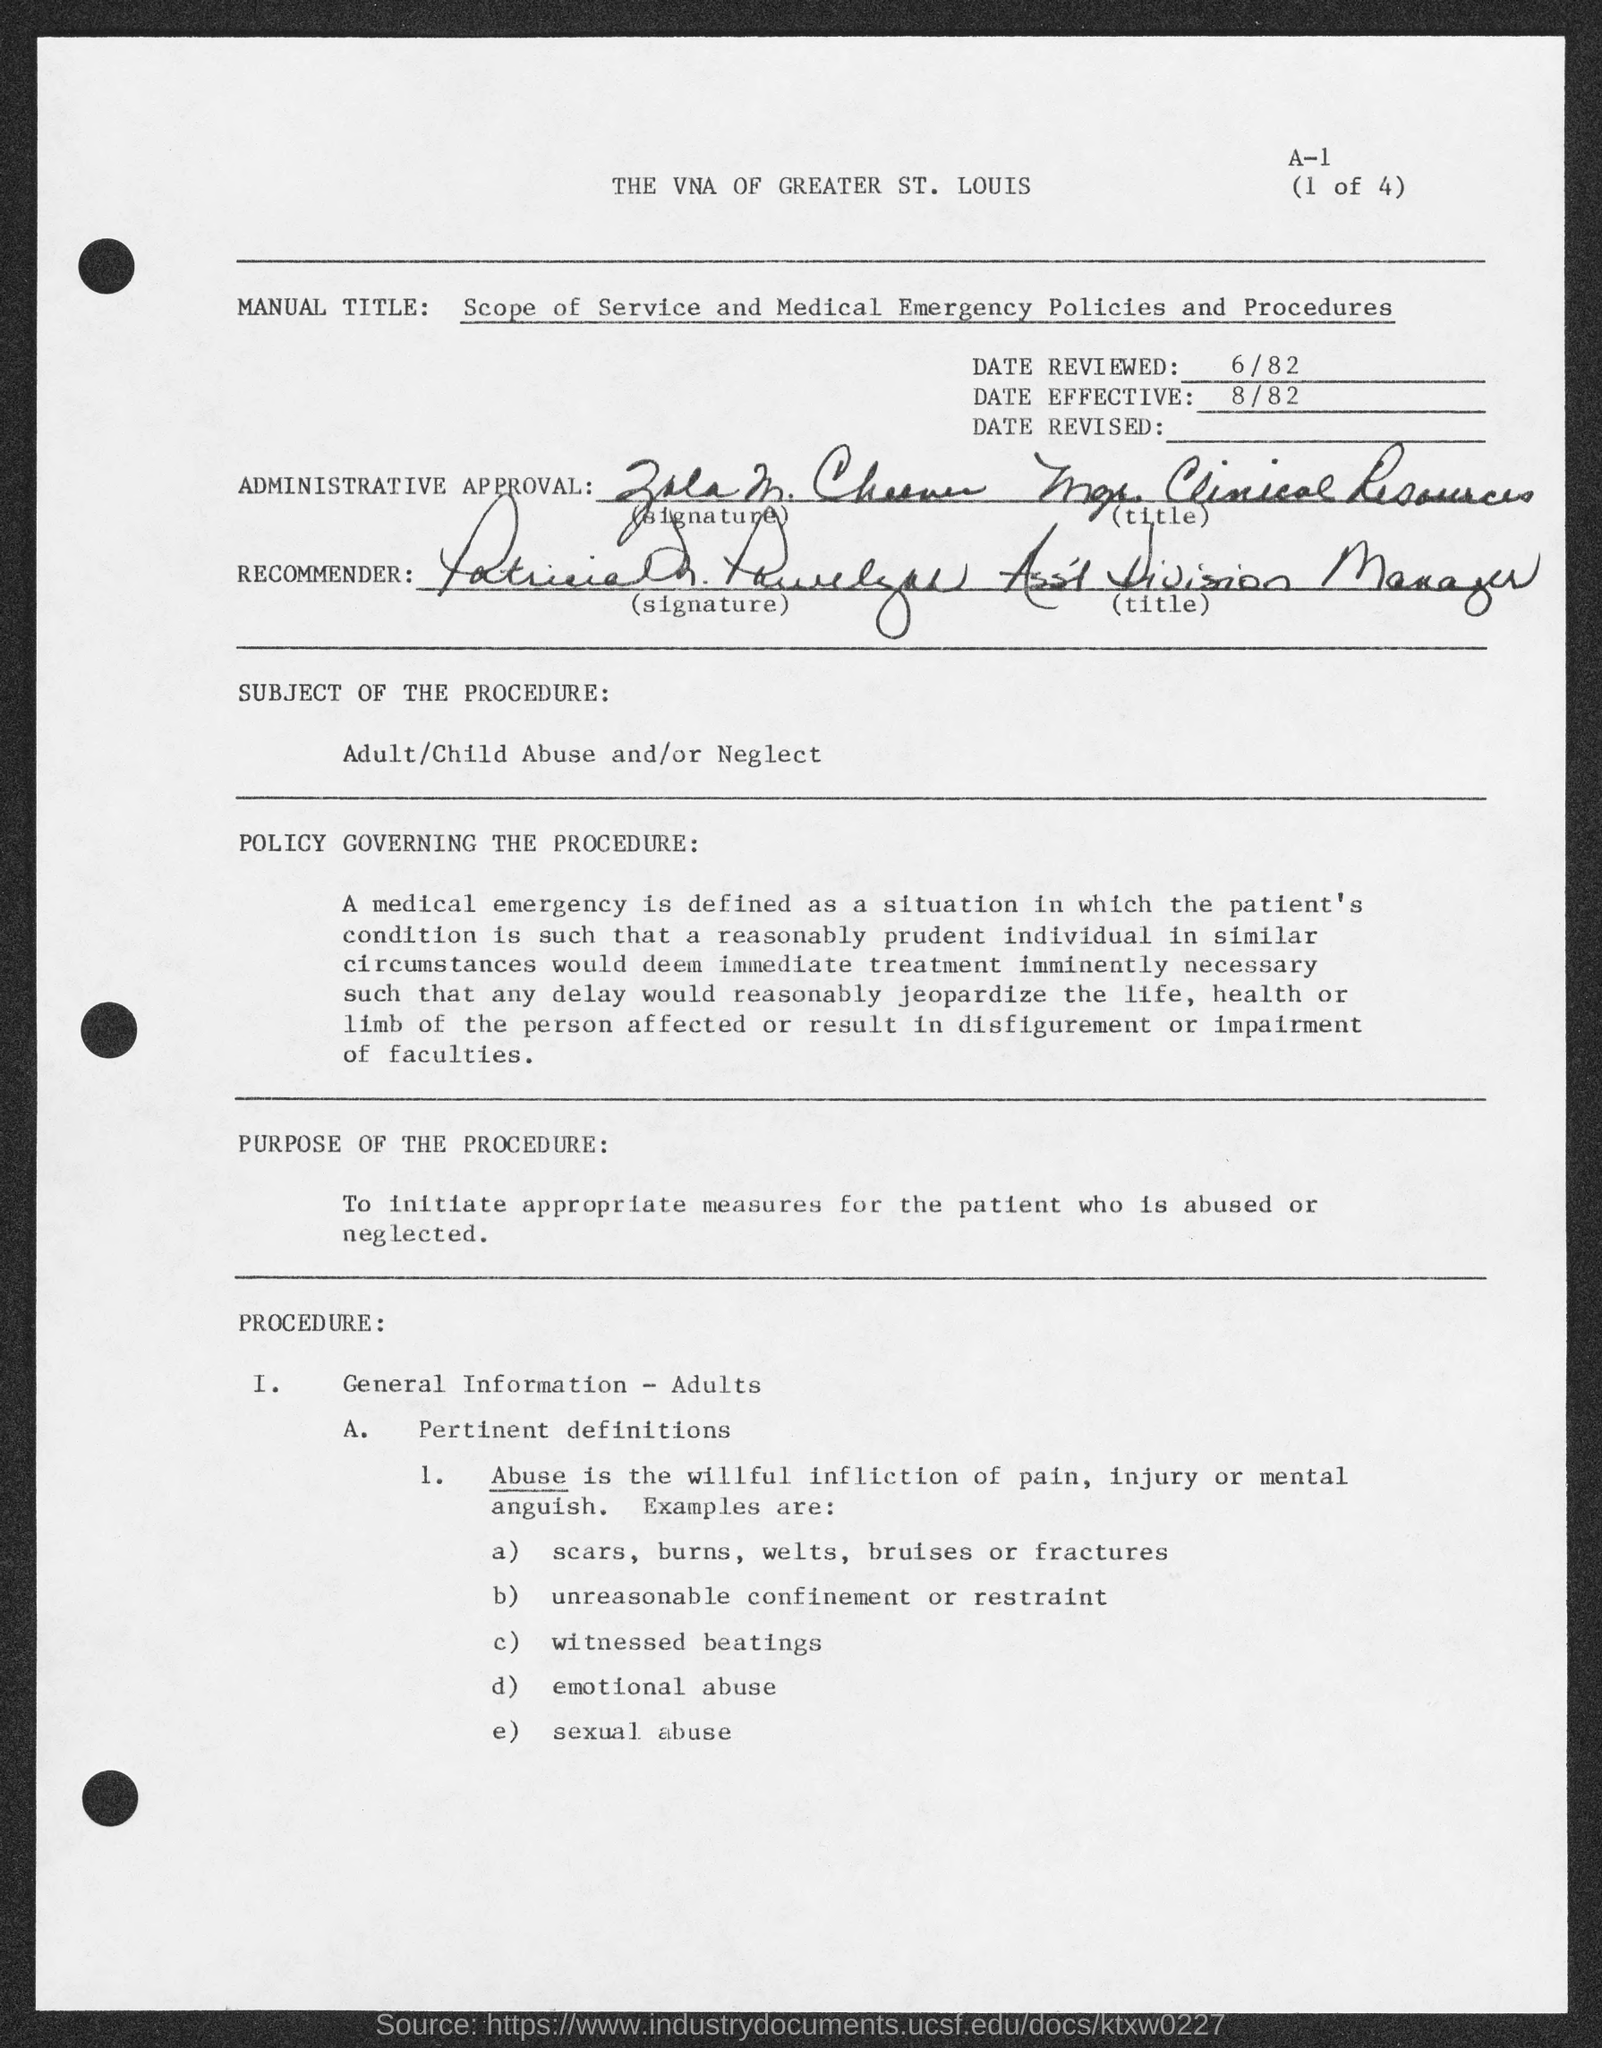What is the "Date Effective"? The document shows that the 'Date Effective' is August 1982, as indicated by the notation '8/82' near the top of the page, under the heading 'DATE EFFECTIVE'. 